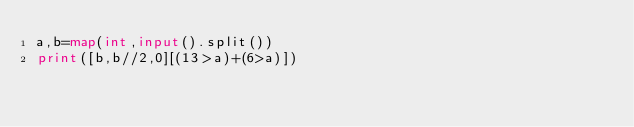<code> <loc_0><loc_0><loc_500><loc_500><_Python_>a,b=map(int,input().split())
print([b,b//2,0][(13>a)+(6>a)])</code> 